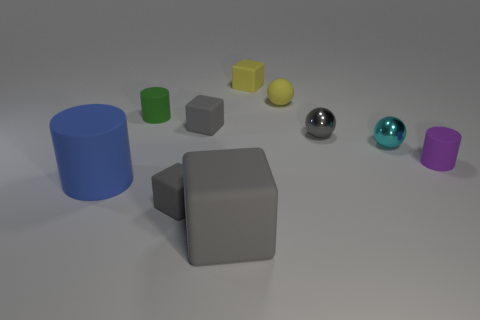How many other things are the same size as the gray ball?
Offer a very short reply. 7. Are there fewer large cyan rubber objects than yellow blocks?
Offer a very short reply. Yes. There is a gray metallic object; what shape is it?
Your answer should be compact. Sphere. There is a big matte object in front of the large blue cylinder; is its color the same as the big cylinder?
Make the answer very short. No. What is the shape of the rubber object that is in front of the green object and behind the tiny cyan ball?
Provide a short and direct response. Cube. There is a big rubber object that is to the right of the big matte cylinder; what color is it?
Offer a very short reply. Gray. Are there any other things of the same color as the tiny matte ball?
Give a very brief answer. Yes. Do the purple rubber thing and the yellow block have the same size?
Provide a succinct answer. Yes. What is the size of the gray matte block that is in front of the purple cylinder and behind the big gray rubber thing?
Your answer should be very brief. Small. What number of small gray cubes are made of the same material as the large blue thing?
Your answer should be compact. 2. 